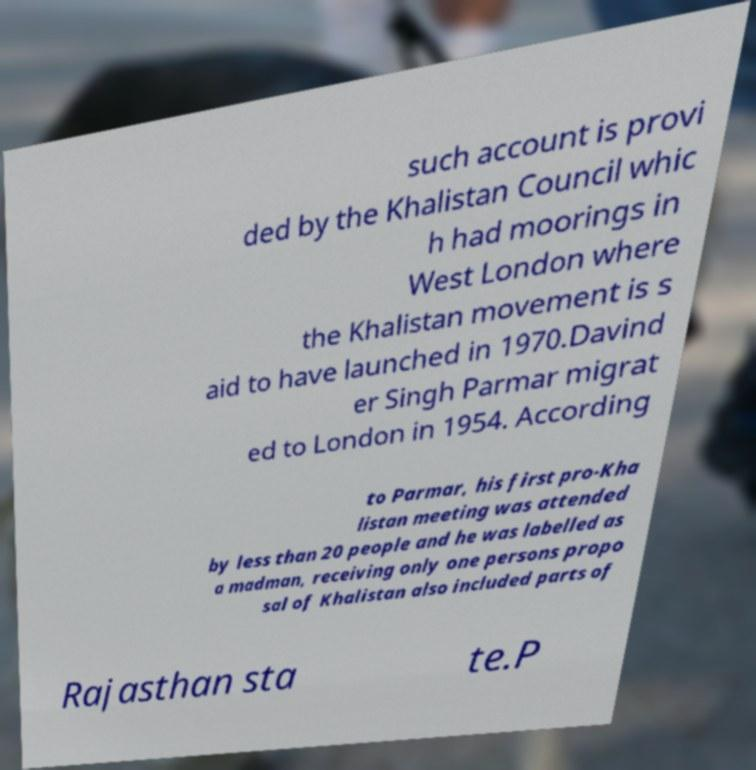Please identify and transcribe the text found in this image. such account is provi ded by the Khalistan Council whic h had moorings in West London where the Khalistan movement is s aid to have launched in 1970.Davind er Singh Parmar migrat ed to London in 1954. According to Parmar, his first pro-Kha listan meeting was attended by less than 20 people and he was labelled as a madman, receiving only one persons propo sal of Khalistan also included parts of Rajasthan sta te.P 